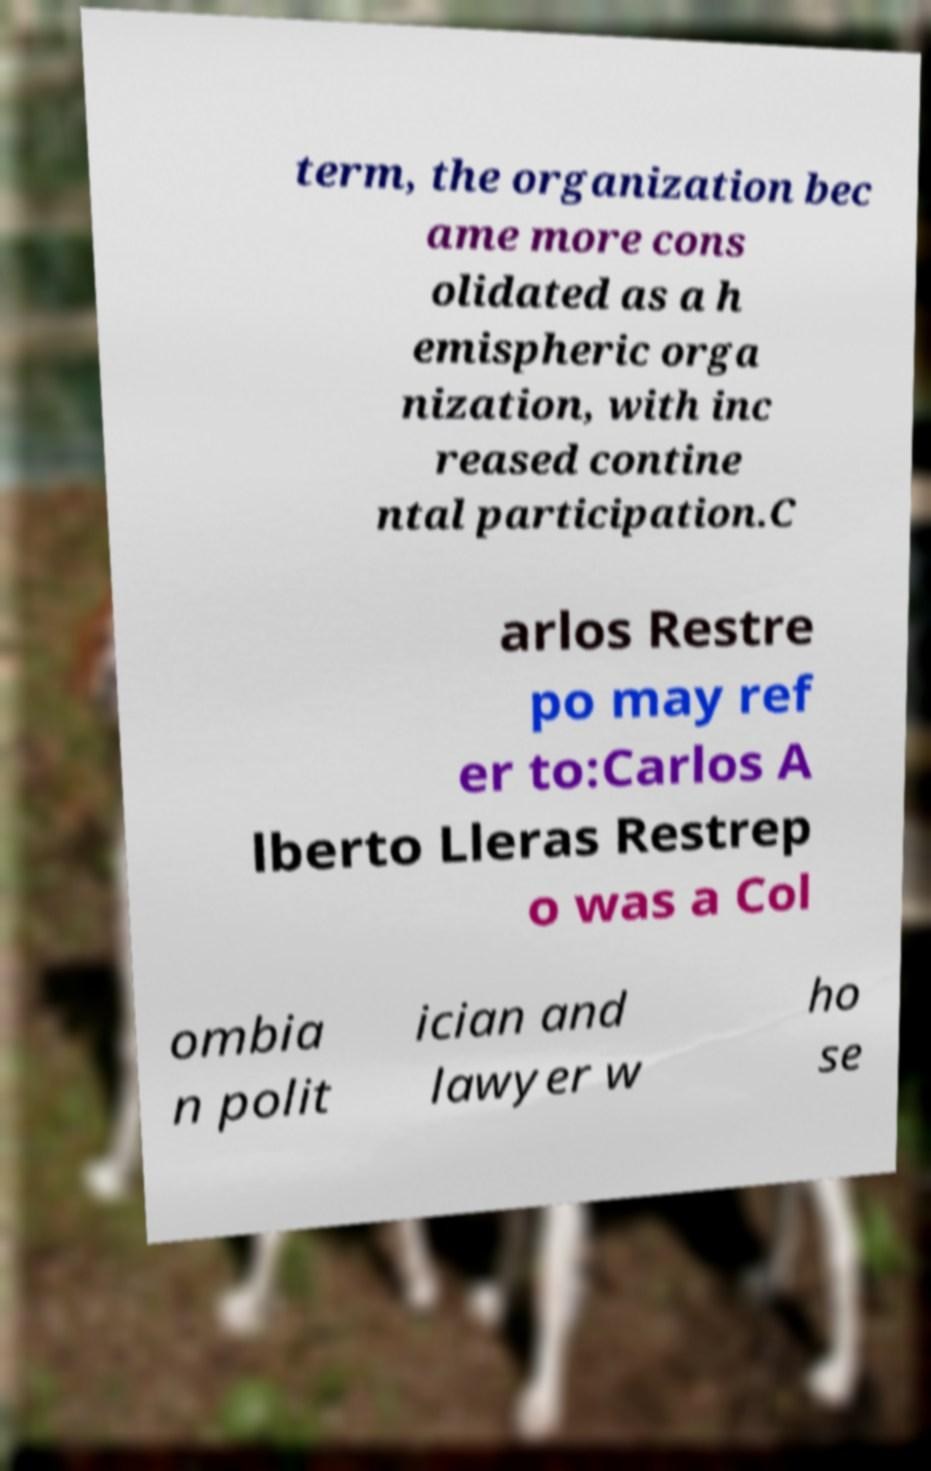Can you read and provide the text displayed in the image?This photo seems to have some interesting text. Can you extract and type it out for me? term, the organization bec ame more cons olidated as a h emispheric orga nization, with inc reased contine ntal participation.C arlos Restre po may ref er to:Carlos A lberto Lleras Restrep o was a Col ombia n polit ician and lawyer w ho se 